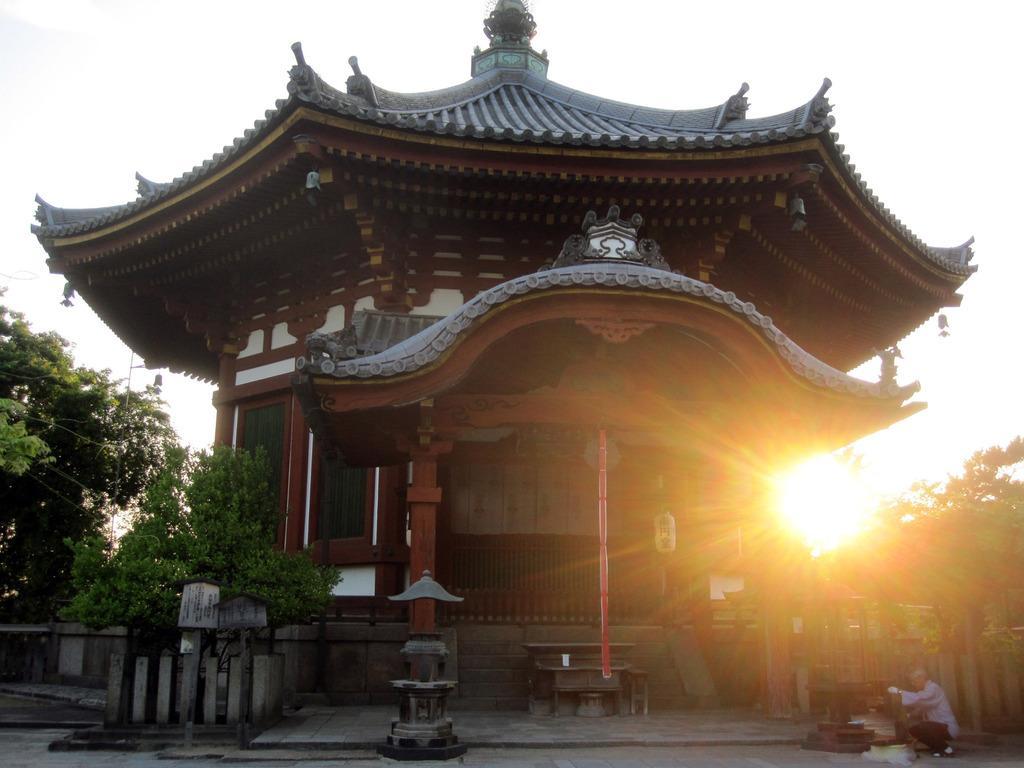Can you describe this image briefly? In this image we can see a house. There are many trees and plants in the image. We can see the sun at the right side of the image. We can see a person at the right side of the image. There is an object at the left side of the image. 